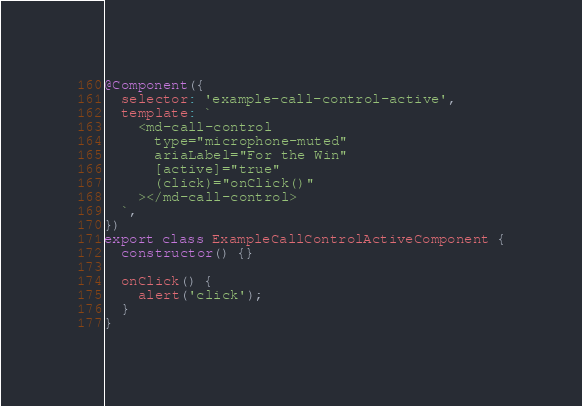Convert code to text. <code><loc_0><loc_0><loc_500><loc_500><_TypeScript_>
@Component({
  selector: 'example-call-control-active',
  template: `
    <md-call-control
      type="microphone-muted"
      ariaLabel="For the Win"
      [active]="true"
      (click)="onClick()"
    ></md-call-control>
  `,
})
export class ExampleCallControlActiveComponent {
  constructor() {}

  onClick() {
    alert('click');
  }
}
</code> 